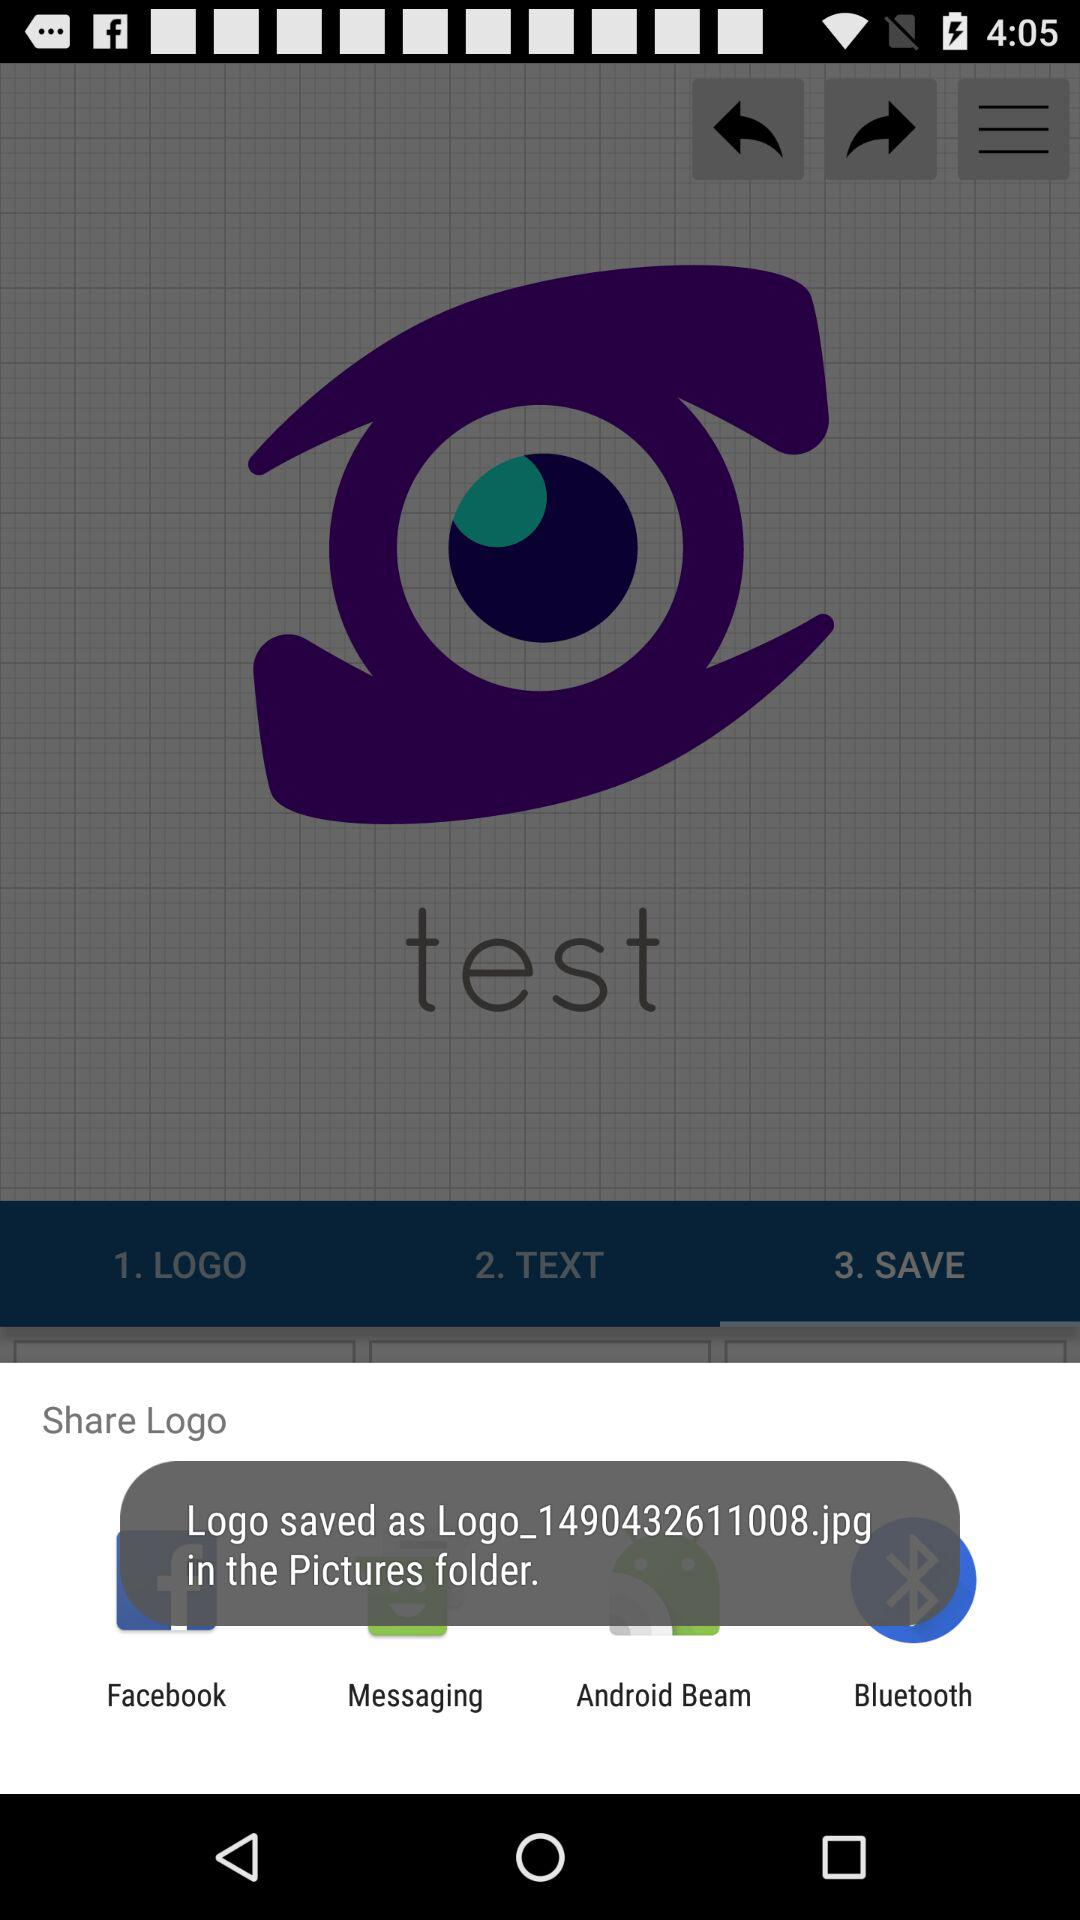What are the apps that can be used to share the logo? The apps that can be used to share the logo are "Facebook", "Messaging", "Android Beam" and "Bluetooth". 